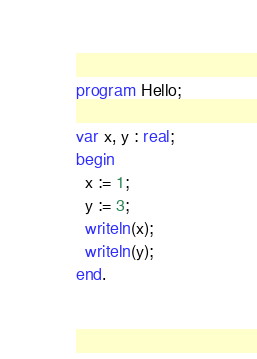Convert code to text. <code><loc_0><loc_0><loc_500><loc_500><_Pascal_>program Hello;

var x, y : real;
begin
  x := 1;
  y := 3;
  writeln(x);
  writeln(y);
end.

</code> 